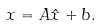Convert formula to latex. <formula><loc_0><loc_0><loc_500><loc_500>x = A \hat { x } + b .</formula> 